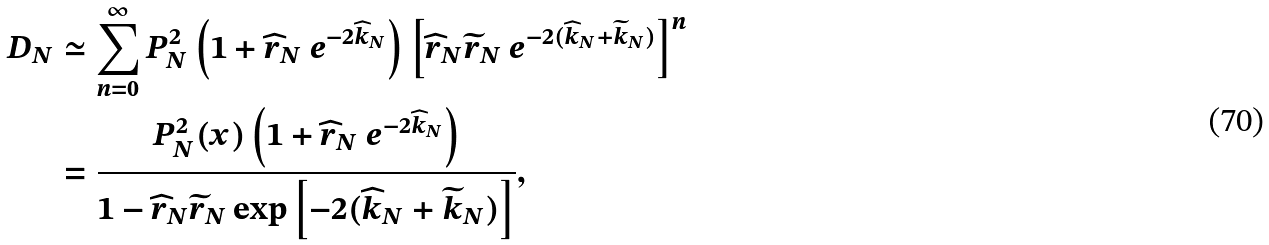<formula> <loc_0><loc_0><loc_500><loc_500>D _ { N } & \simeq \sum _ { n = 0 } ^ { \infty } P _ { N } ^ { 2 } \left ( 1 + \widehat { r } _ { N } \ e ^ { - 2 \widehat { k } _ { N } } \right ) \left [ \widehat { r } _ { N } \widetilde { r } _ { N } \ e ^ { - 2 ( \widehat { k } _ { N } + \widetilde { k } _ { N } ) } \right ] ^ { n } \\ & = \frac { P _ { N } ^ { 2 } ( x ) \left ( 1 + \widehat { r } _ { N } \ e ^ { - 2 \widehat { k } _ { N } } \right ) } { 1 - \widehat { r } _ { N } \widetilde { r } _ { N } \exp \left [ - 2 ( \widehat { k } _ { N } + \widetilde { k } _ { N } ) \right ] } ,</formula> 